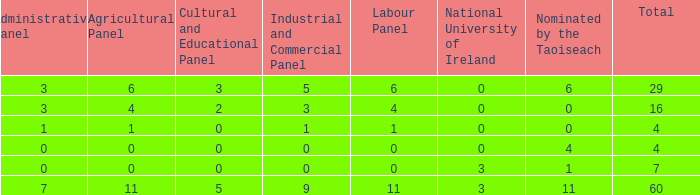What is the maximum number of nominations by taoiseach of the structure with an administrative panel above 0 and an industrial and commercial panel below 1? None. 